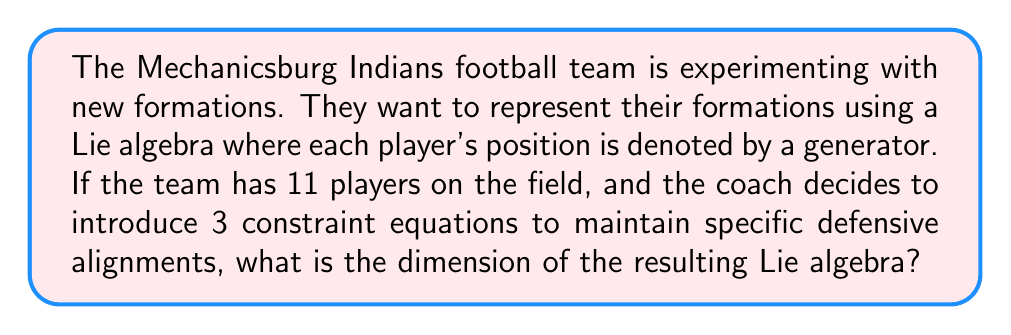Can you answer this question? Let's approach this step-by-step:

1) In a Lie algebra, each generator represents a degree of freedom in the system. In this case, each player's position is represented by a generator.

2) Initially, we have 11 players, so we start with 11 generators. Let's call this initial vector space $V$.

   $\dim(V) = 11$

3) The coach's 3 constraint equations can be thought of as linear dependencies among the generators. These constraints reduce the degrees of freedom in the system.

4) In Lie algebra theory, constraints are represented by an ideal $I$ within the algebra. The dimension of this ideal is equal to the number of independent constraints.

   $\dim(I) = 3$

5) The resulting Lie algebra $L$ is the quotient of the initial vector space $V$ by the ideal $I$:

   $L = V / I$

6) The dimension of a quotient space is given by the difference between the dimensions of the original space and the subspace being quotiented out:

   $\dim(L) = \dim(V) - \dim(I)$

7) Substituting the values:

   $\dim(L) = 11 - 3 = 8$

Therefore, the dimension of the resulting Lie algebra representing the team's formations is 8.
Answer: $8$ 